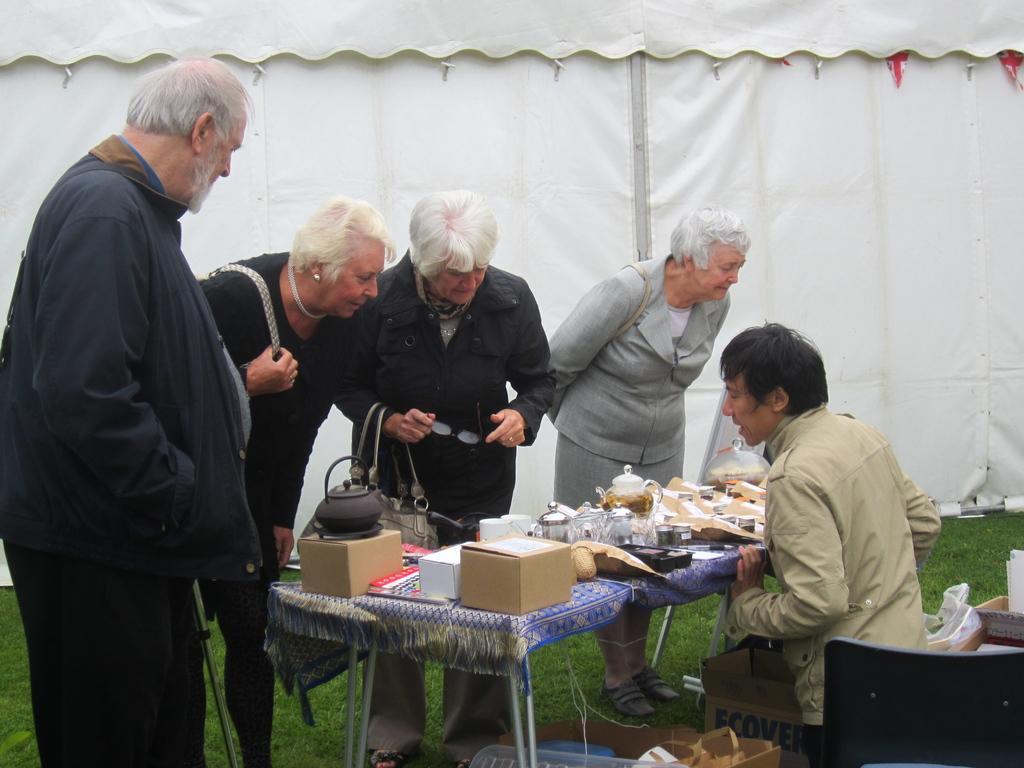Describe this image in one or two sentences. On the background of the picture we can see a white colour tent. Here we can see persons standing in front of a table and observing all the items which are on the table. These are boxes. here we can see one man staring at the table. This is a fresh green grass. 